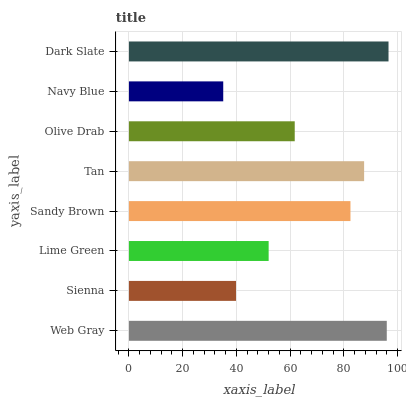Is Navy Blue the minimum?
Answer yes or no. Yes. Is Dark Slate the maximum?
Answer yes or no. Yes. Is Sienna the minimum?
Answer yes or no. No. Is Sienna the maximum?
Answer yes or no. No. Is Web Gray greater than Sienna?
Answer yes or no. Yes. Is Sienna less than Web Gray?
Answer yes or no. Yes. Is Sienna greater than Web Gray?
Answer yes or no. No. Is Web Gray less than Sienna?
Answer yes or no. No. Is Sandy Brown the high median?
Answer yes or no. Yes. Is Olive Drab the low median?
Answer yes or no. Yes. Is Olive Drab the high median?
Answer yes or no. No. Is Lime Green the low median?
Answer yes or no. No. 